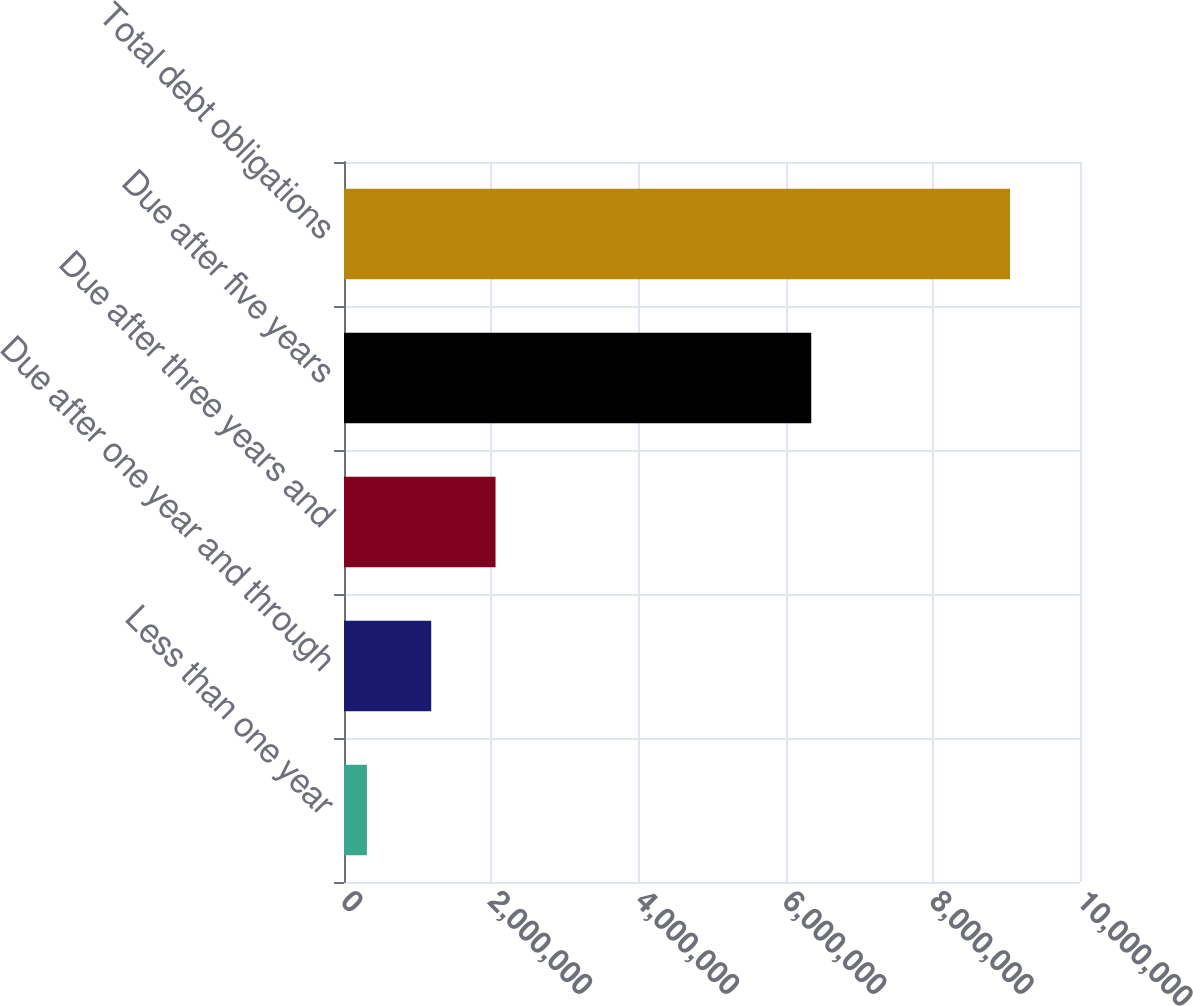Convert chart to OTSL. <chart><loc_0><loc_0><loc_500><loc_500><bar_chart><fcel>Less than one year<fcel>Due after one year and through<fcel>Due after three years and<fcel>Due after five years<fcel>Total debt obligations<nl><fcel>311339<fcel>1.18509e+06<fcel>2.05884e+06<fcel>6.34858e+06<fcel>9.04883e+06<nl></chart> 